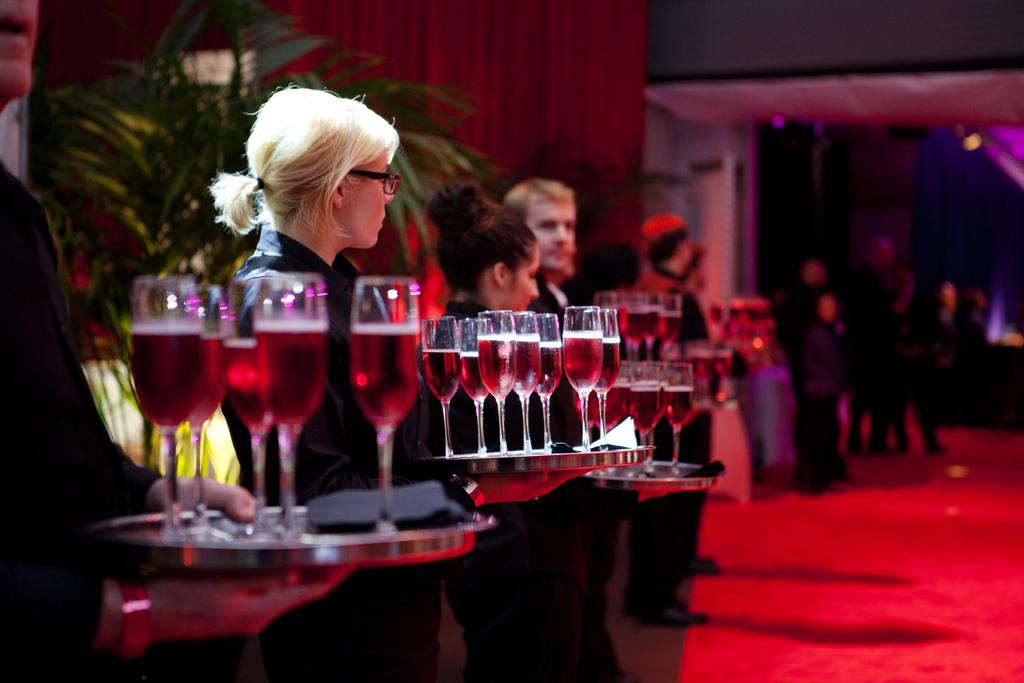What are the people in the image doing? The people in the image are standing. What are some of the people holding in the image? Some of the people are holding plates with juice glasses. What type of vegetation is present in the image? There are plants in the image. What type of lighting is present in the image? There are lights in the image. What type of window treatment is present in the image? There is a curtain in the image. What type of judgment is the judge making in the image? There is no judge present in the image, so no judgment can be made. 